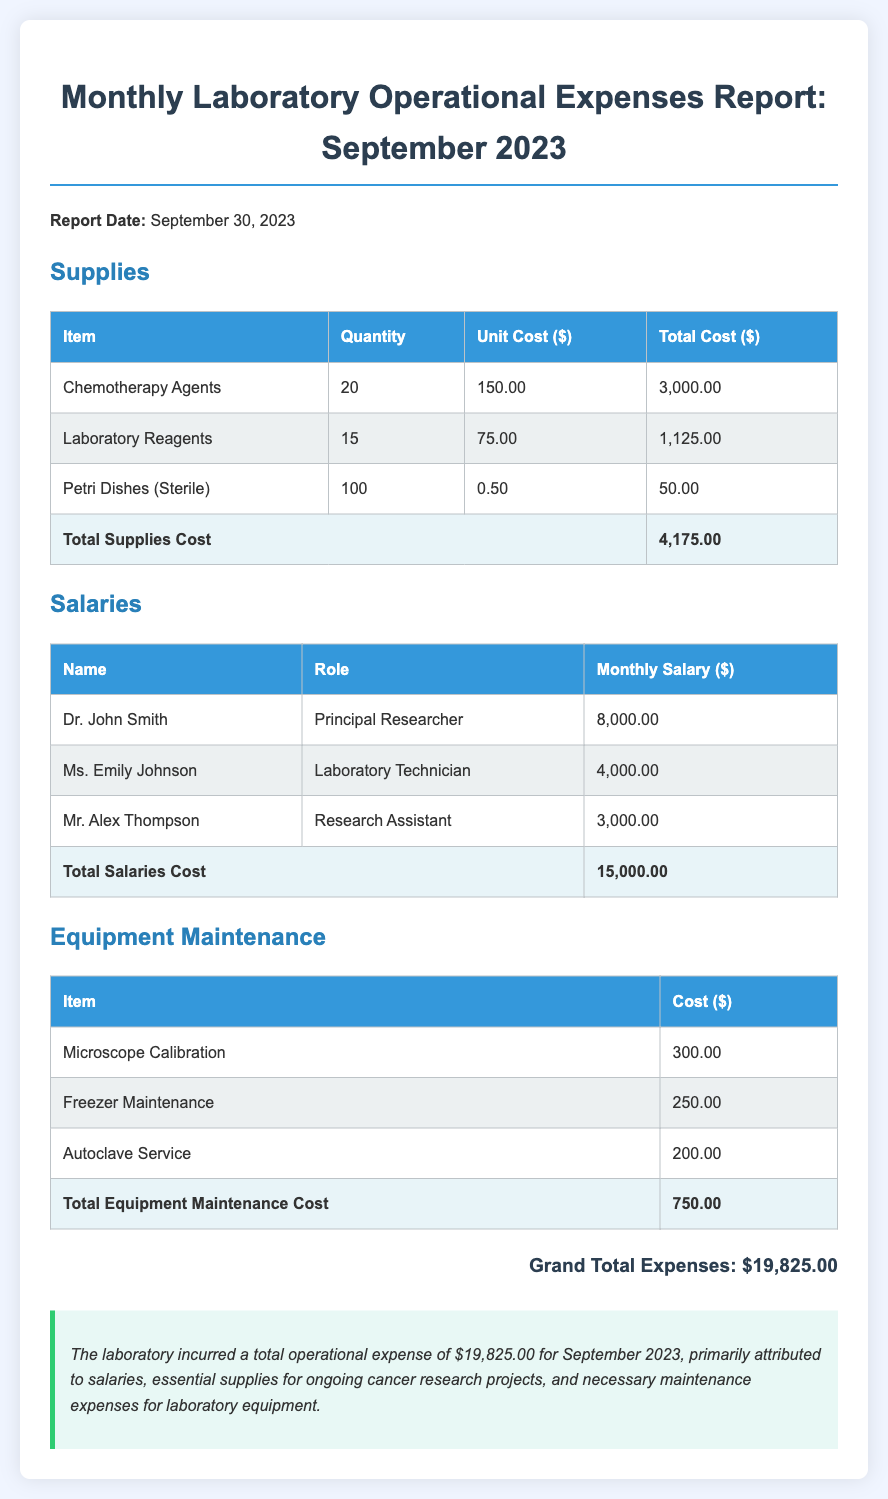What is the total supplies cost? The total supplies cost is provided in the document and is the sum of all itemized costs under the Supplies section, which totals $4,175.00.
Answer: $4,175.00 What is the monthly salary of Dr. John Smith? The document lists Dr. John Smith's monthly salary under the Salaries section, which is $8,000.00.
Answer: $8,000.00 How many Petri Dishes were purchased? The document specifies that 100 Petri Dishes were purchased as part of the Supplies section.
Answer: 100 What is the total cost for equipment maintenance? The total cost for equipment maintenance is summarized at the end of the Equipment Maintenance section, which totals $750.00.
Answer: $750.00 What are the total salaries? The total salaries cost is provided at the end of the Salaries section, totaling $15,000.00.
Answer: $15,000.00 What percentage of the total expenses do salaries represent? The salaries total ($15,000.00) divided by the grand total expenses ($19,825.00) provides the percentage of total expenses accounted for by salaries, which is approximately 75.7%.
Answer: 75.7% What item is listed with the lowest cost in the Supplies section? The item listed with the lowest cost in the Supplies section is Petri Dishes (Sterile) at a total cost of $50.00.
Answer: Petri Dishes (Sterile) What is the report date? The report date is explicitly mentioned in the document, which is September 30, 2023.
Answer: September 30, 2023 What is included in the commentary section? The commentary section provides an overview and insight about the total operational expenses for September 2023, highlighting essential costs in salaries, supplies, and maintenance.
Answer: Overview of operational expenses 